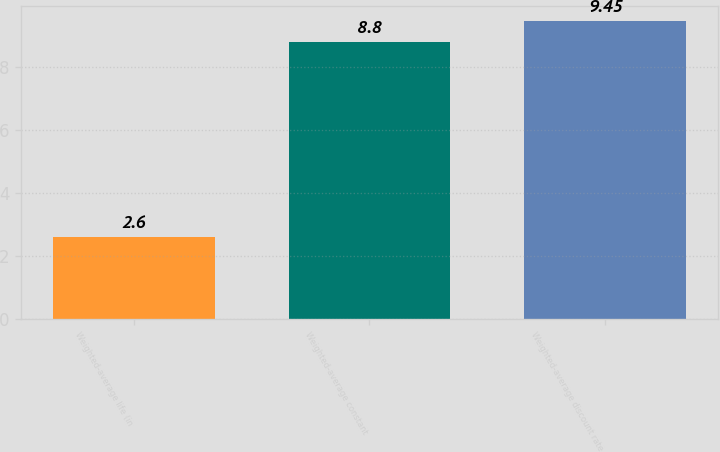Convert chart to OTSL. <chart><loc_0><loc_0><loc_500><loc_500><bar_chart><fcel>Weighted-average life (in<fcel>Weighted-average constant<fcel>Weighted-average discount rate<nl><fcel>2.6<fcel>8.8<fcel>9.45<nl></chart> 